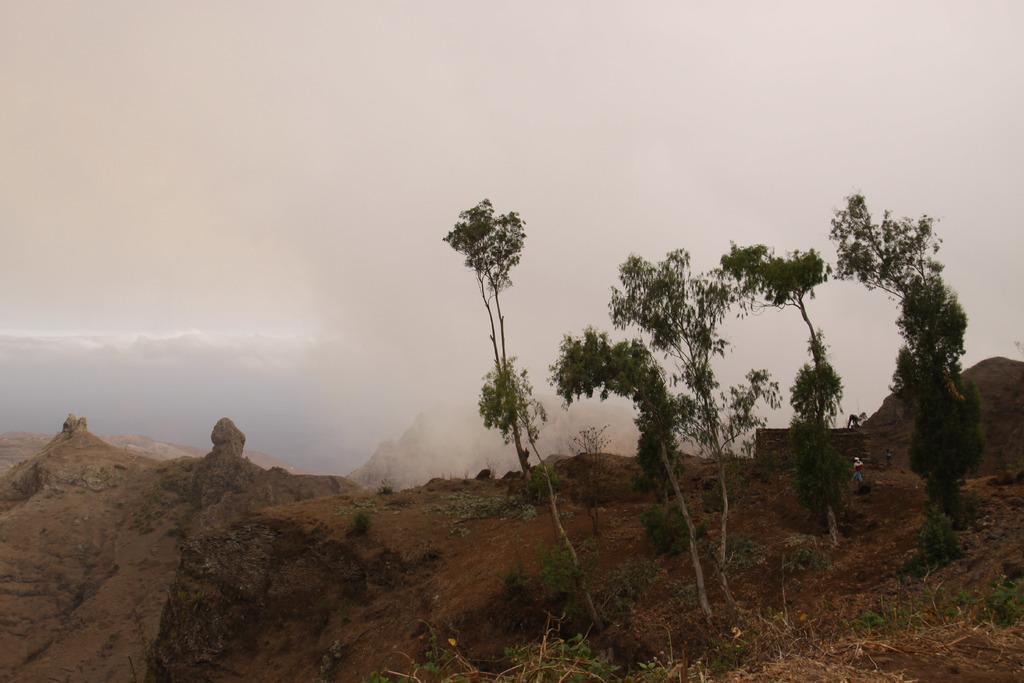Describe this image in one or two sentences. In this picture I can see an open, on which there are few plants and trees. In the background I can see clouds. 